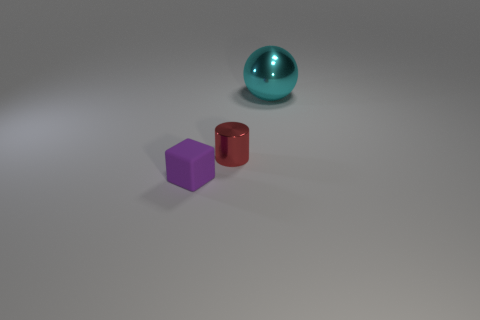Is there any other thing that has the same size as the cyan thing?
Give a very brief answer. No. The small thing behind the object that is to the left of the tiny red cylinder is made of what material?
Your answer should be compact. Metal. Does the metal object that is in front of the cyan sphere have the same size as the small purple matte block?
Provide a succinct answer. Yes. What number of matte things are either red cylinders or tiny yellow things?
Make the answer very short. 0. There is a object that is to the left of the big cyan thing and to the right of the tiny purple thing; what material is it made of?
Keep it short and to the point. Metal. Is the cylinder made of the same material as the cyan object?
Offer a terse response. Yes. What shape is the tiny metallic thing?
Your answer should be very brief. Cylinder. What number of objects are either cyan cubes or metallic things that are in front of the big cyan metal object?
Your response must be concise. 1. The thing that is both right of the small purple block and in front of the large cyan metal sphere is what color?
Your response must be concise. Red. There is a tiny object that is behind the small purple cube; what is it made of?
Offer a terse response. Metal. 